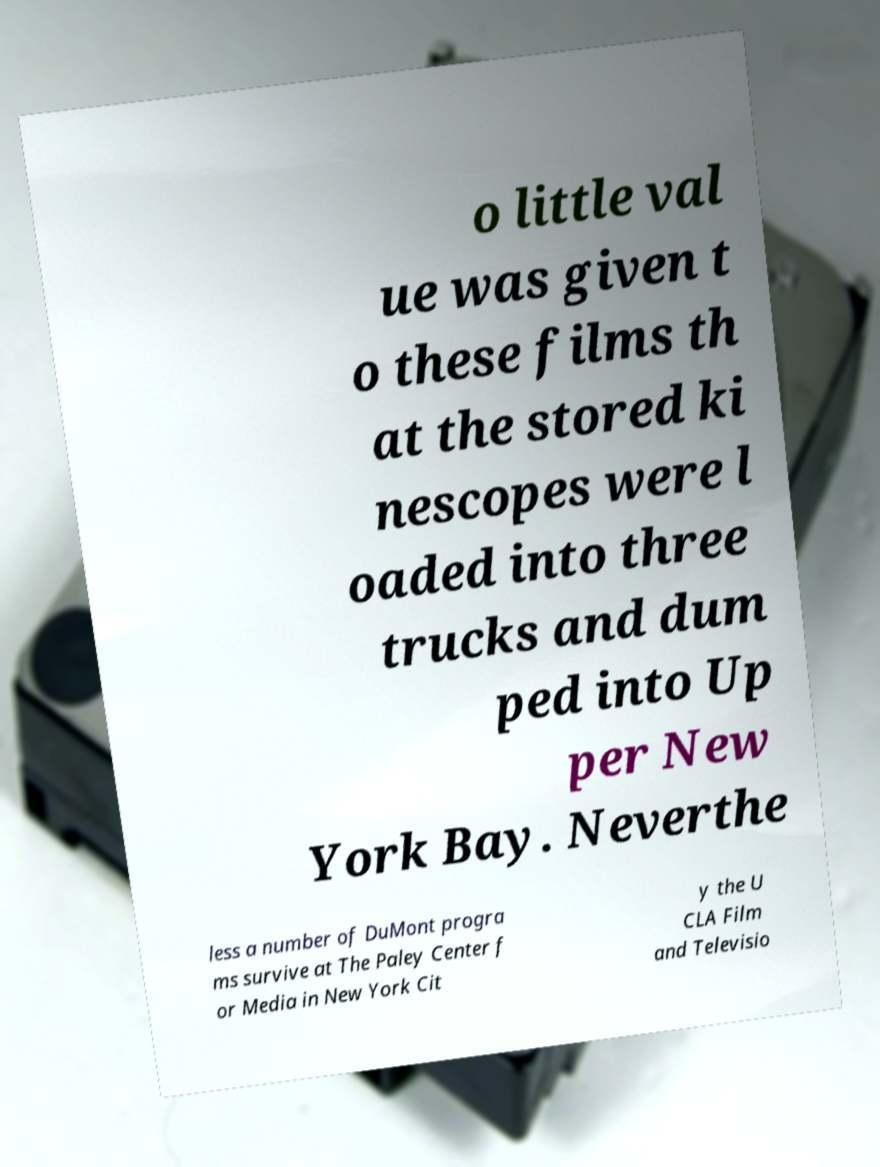For documentation purposes, I need the text within this image transcribed. Could you provide that? o little val ue was given t o these films th at the stored ki nescopes were l oaded into three trucks and dum ped into Up per New York Bay. Neverthe less a number of DuMont progra ms survive at The Paley Center f or Media in New York Cit y the U CLA Film and Televisio 